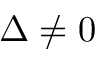Convert formula to latex. <formula><loc_0><loc_0><loc_500><loc_500>\Delta \neq 0</formula> 